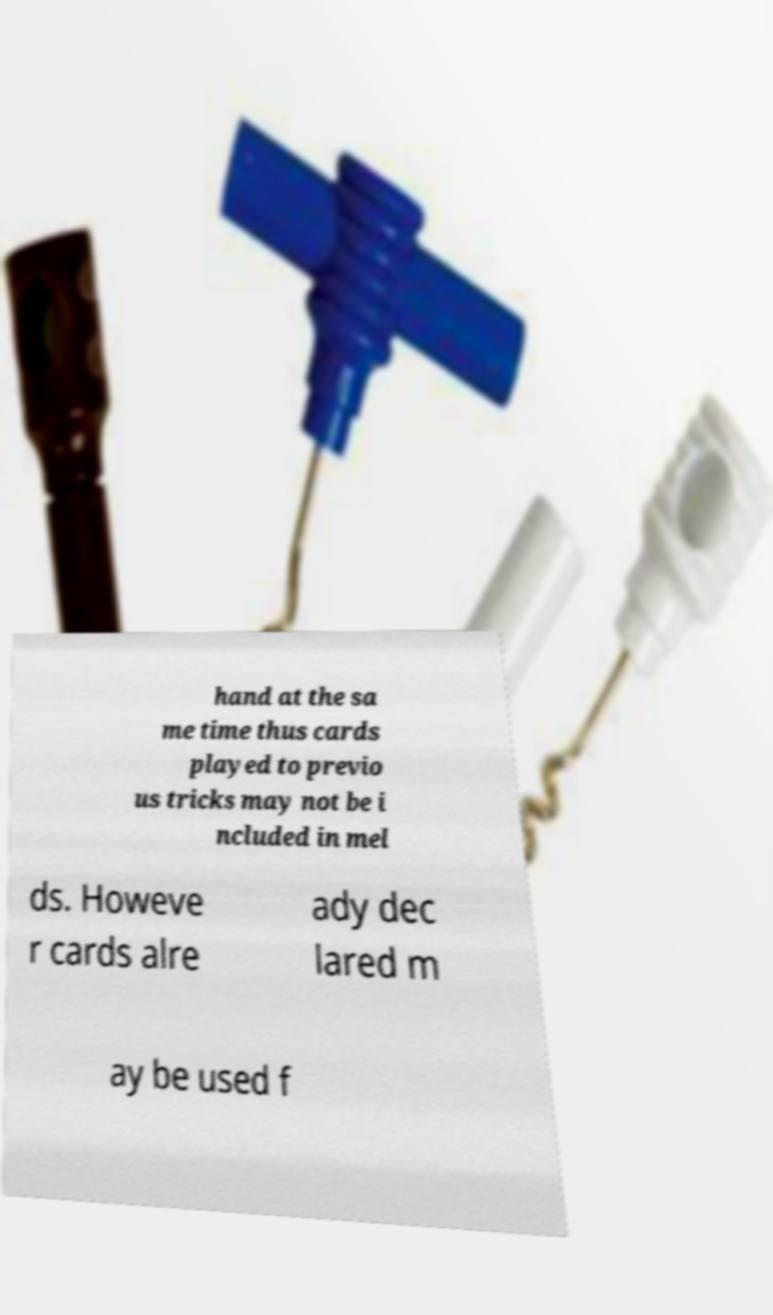Could you assist in decoding the text presented in this image and type it out clearly? hand at the sa me time thus cards played to previo us tricks may not be i ncluded in mel ds. Howeve r cards alre ady dec lared m ay be used f 